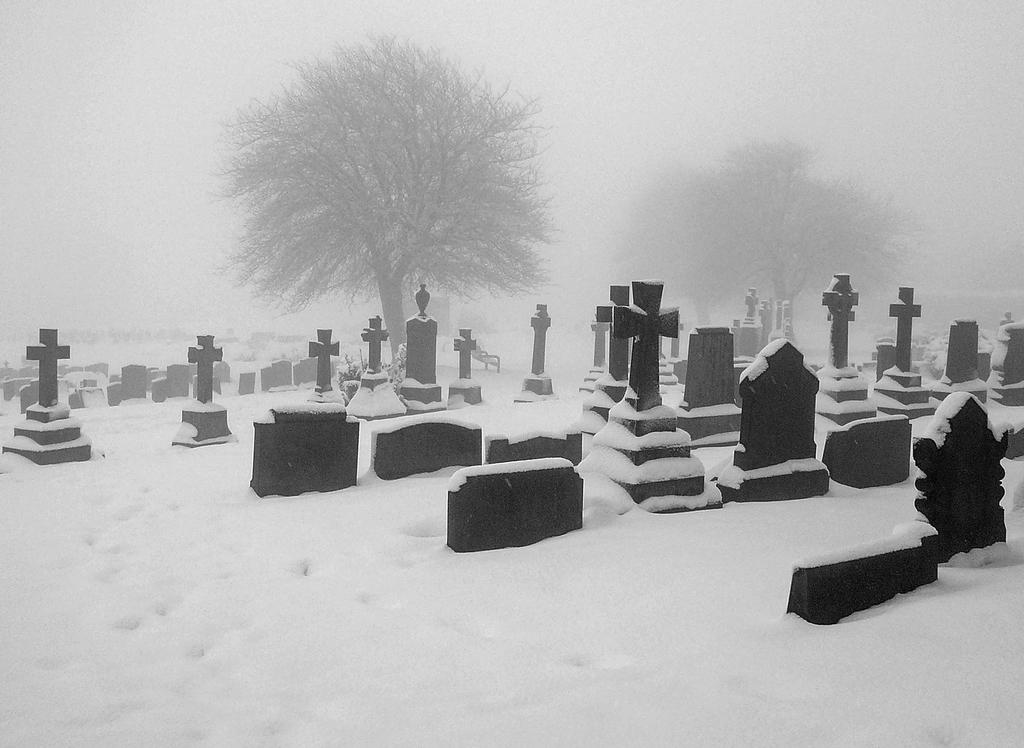What type of location is depicted in the image? There is a graveyard in the image. What is the weather like in the image? There is snow visible in the image. What type of vegetation can be seen in the image? There are trees in the image. How would you describe the sky in the image? The sky is foggy in the image. Where is the steel structure located in the image? There is no steel structure present in the image. What type of meeting is taking place in the image? There is no meeting depicted in the image. 